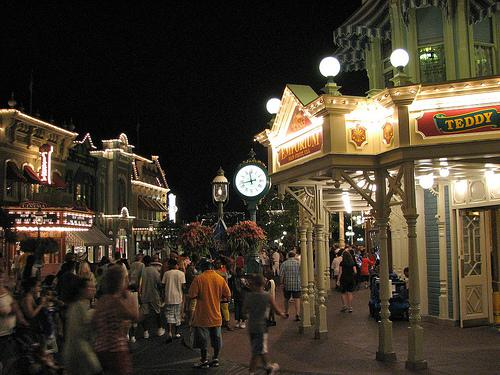Question: what time is it?
Choices:
A. 8:58.
B. 9:00.
C. 9:02.
D. 9:30.
Answer with the letter. Answer: B Question: why are the street lights on?
Choices:
A. To provide light.
B. To light up the street.
C. For safety.
D. It's dark.
Answer with the letter. Answer: D Question: when was this taken?
Choices:
A. Morning.
B. At night.
C. Evening.
D. Summer.
Answer with the letter. Answer: B Question: what is hanging from the street light?
Choices:
A. Banners.
B. Signs.
C. Flower baskets.
D. Lights.
Answer with the letter. Answer: C 